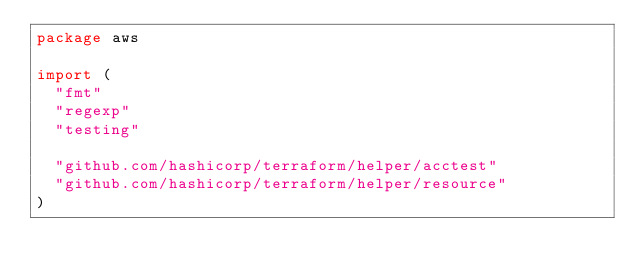<code> <loc_0><loc_0><loc_500><loc_500><_Go_>package aws

import (
	"fmt"
	"regexp"
	"testing"

	"github.com/hashicorp/terraform/helper/acctest"
	"github.com/hashicorp/terraform/helper/resource"
)
</code> 